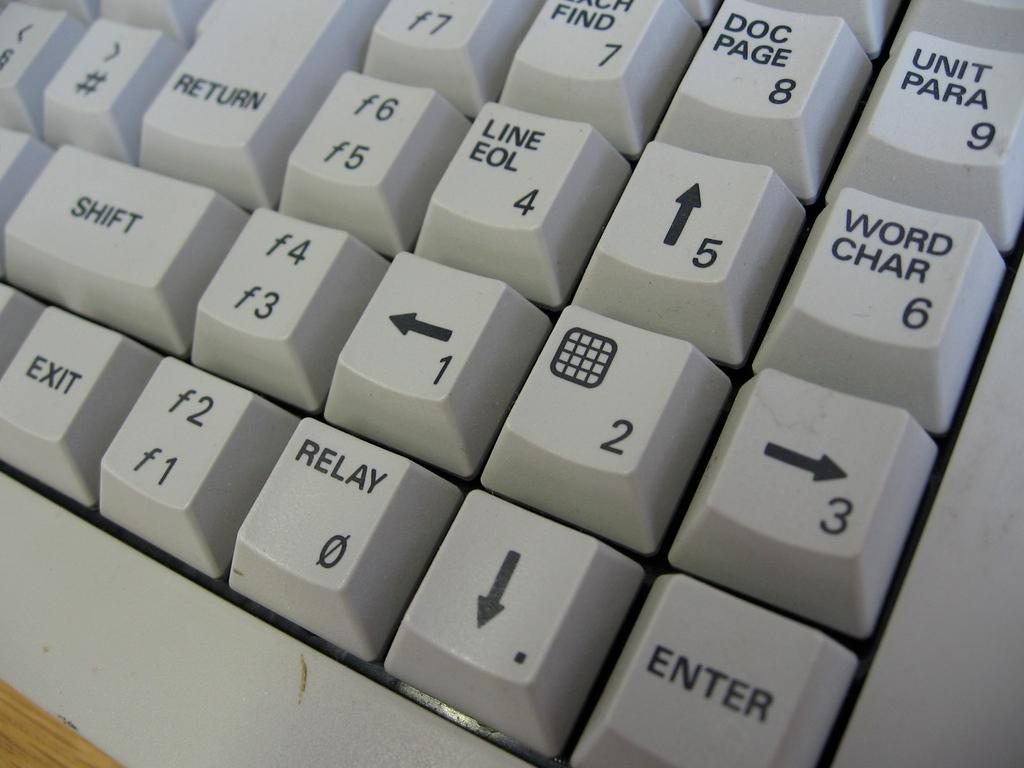<image>
Render a clear and concise summary of the photo. A keyboard has the word relay on one of the keys and is next to a key with an arrow. 